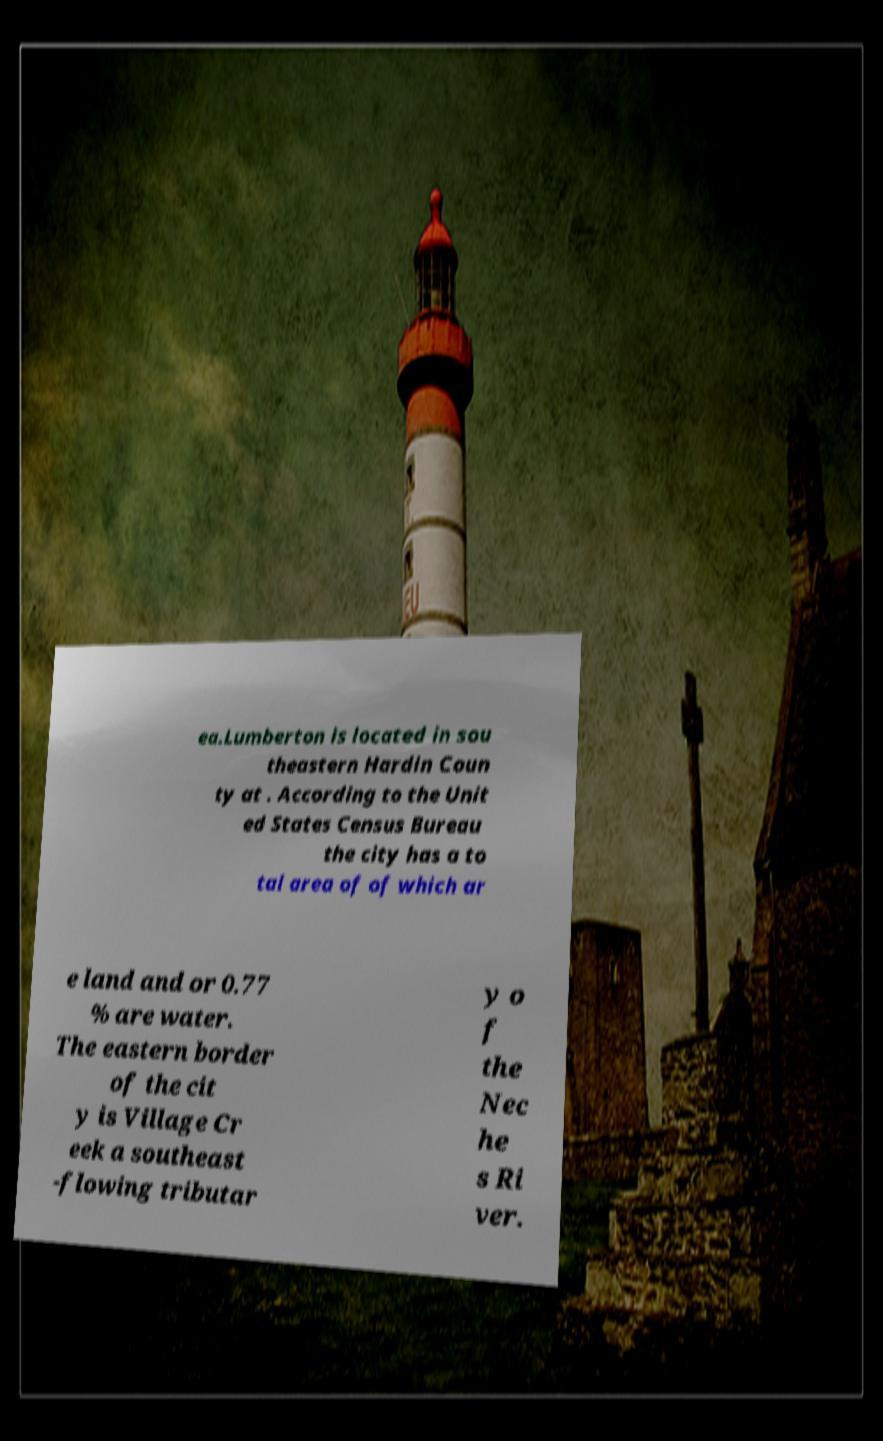Could you extract and type out the text from this image? ea.Lumberton is located in sou theastern Hardin Coun ty at . According to the Unit ed States Census Bureau the city has a to tal area of of which ar e land and or 0.77 % are water. The eastern border of the cit y is Village Cr eek a southeast -flowing tributar y o f the Nec he s Ri ver. 